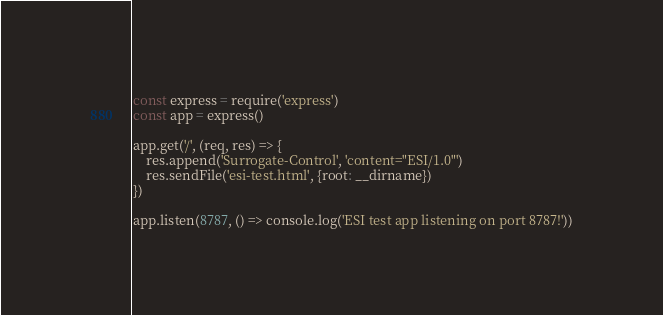<code> <loc_0><loc_0><loc_500><loc_500><_JavaScript_>const express = require('express')
const app = express()

app.get('/', (req, res) => {
    res.append('Surrogate-Control', 'content="ESI/1.0"')
    res.sendFile('esi-test.html', {root: __dirname})
})

app.listen(8787, () => console.log('ESI test app listening on port 8787!'))</code> 